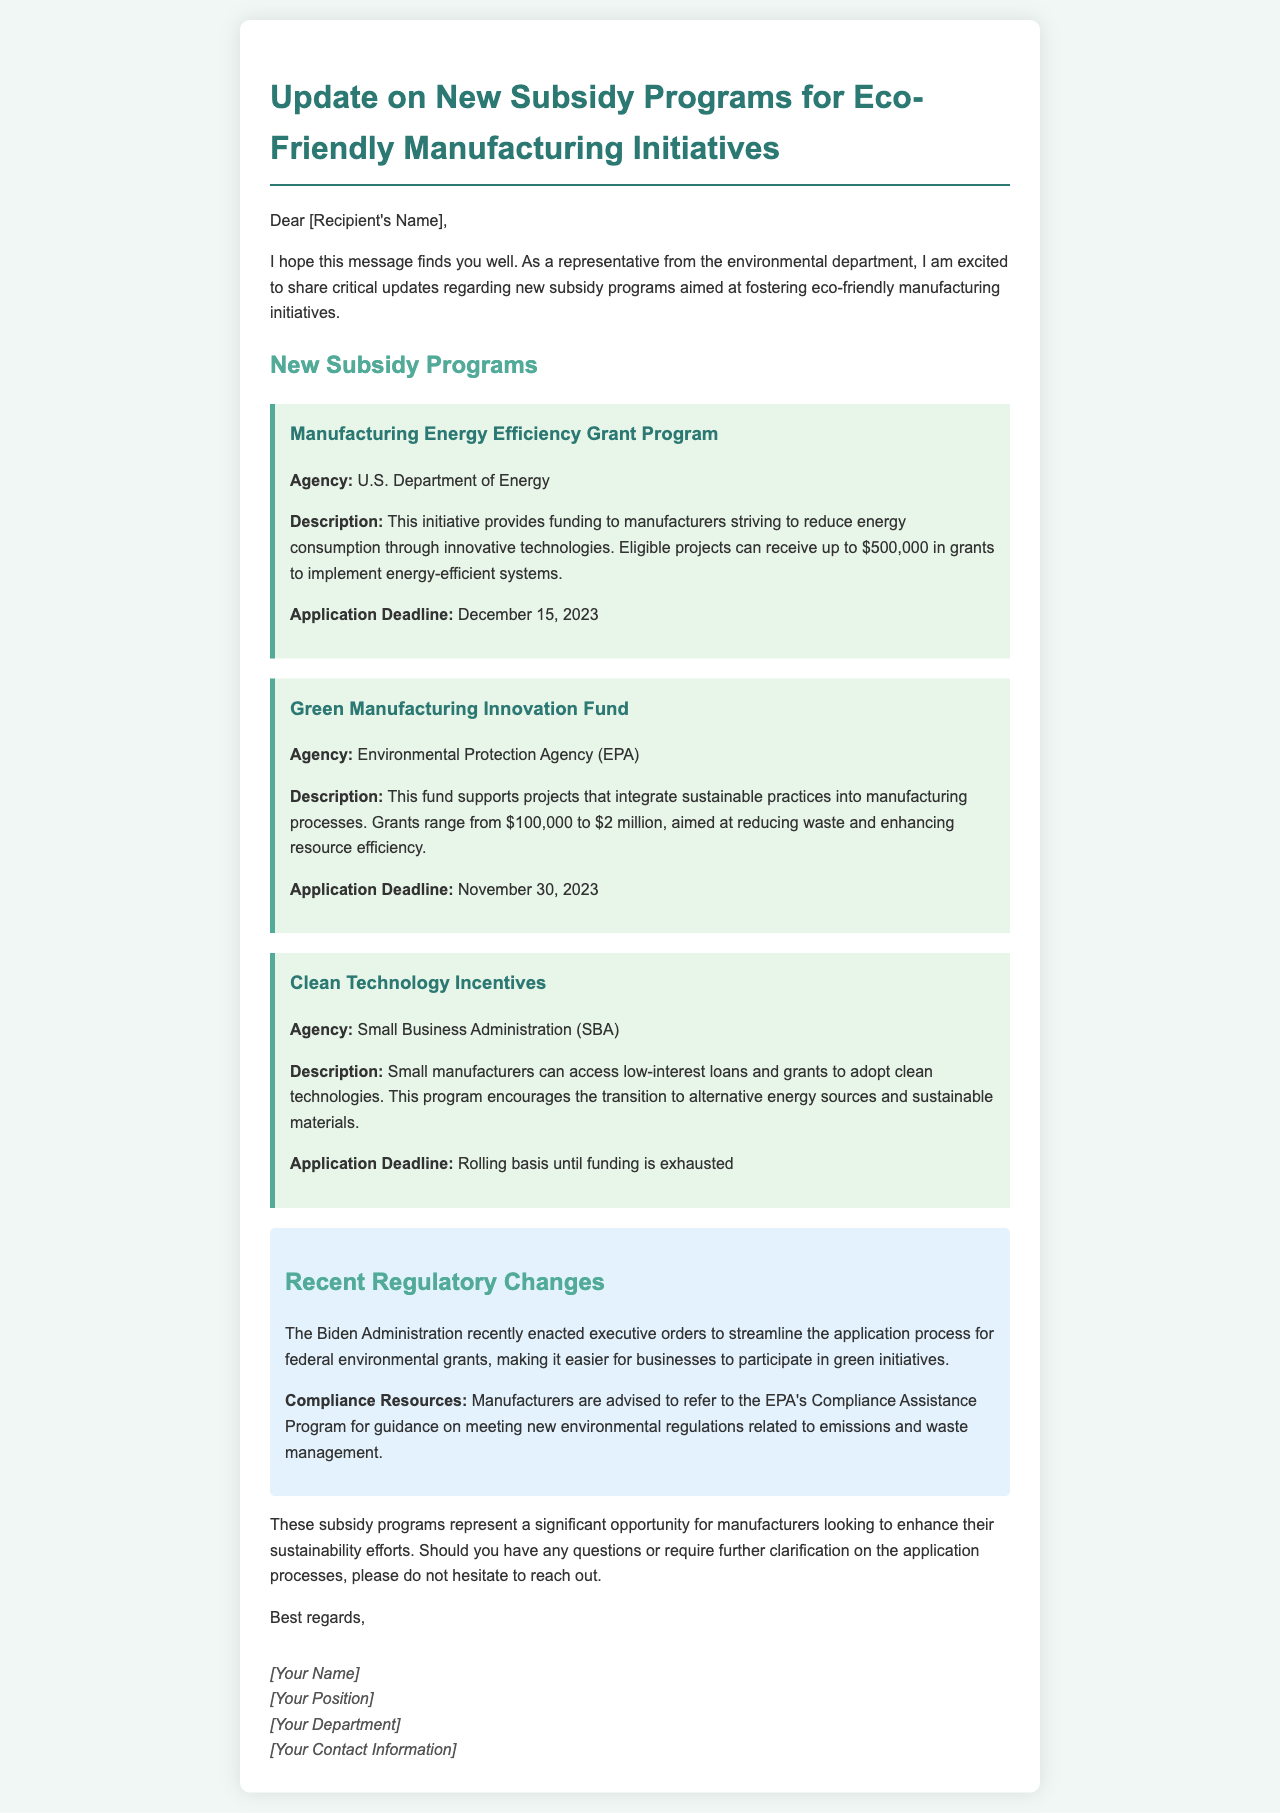What is the maximum grant amount for the Manufacturing Energy Efficiency Grant Program? The document states that eligible projects can receive up to $500,000 in grants.
Answer: $500,000 What is the application deadline for the Green Manufacturing Innovation Fund? According to the document, the application deadline is November 30, 2023.
Answer: November 30, 2023 Which agency oversees the Clean Technology Incentives? The document specifies that the Small Business Administration (SBA) oversees this program.
Answer: Small Business Administration (SBA) What type of funding is provided through the Clean Technology Incentives? The document indicates that small manufacturers can access low-interest loans and grants.
Answer: low-interest loans and grants What recent regulatory changes have been enacted? The document mentions that the Biden Administration enacted executive orders to streamline the application process for federal environmental grants.
Answer: Executive orders to streamline the application process Why are manufacturers advised to refer to the EPA's Compliance Assistance Program? The document explains it is for guidance on meeting new environmental regulations related to emissions and waste management.
Answer: Guidance on new environmental regulations How much funding can projects receive from the Green Manufacturing Innovation Fund? The document states that grants range from $100,000 to $2 million.
Answer: $100,000 to $2 million What is highlighted as a significant opportunity for manufacturers? The document emphasizes the new subsidy programs for enhancing sustainability efforts.
Answer: New subsidy programs 